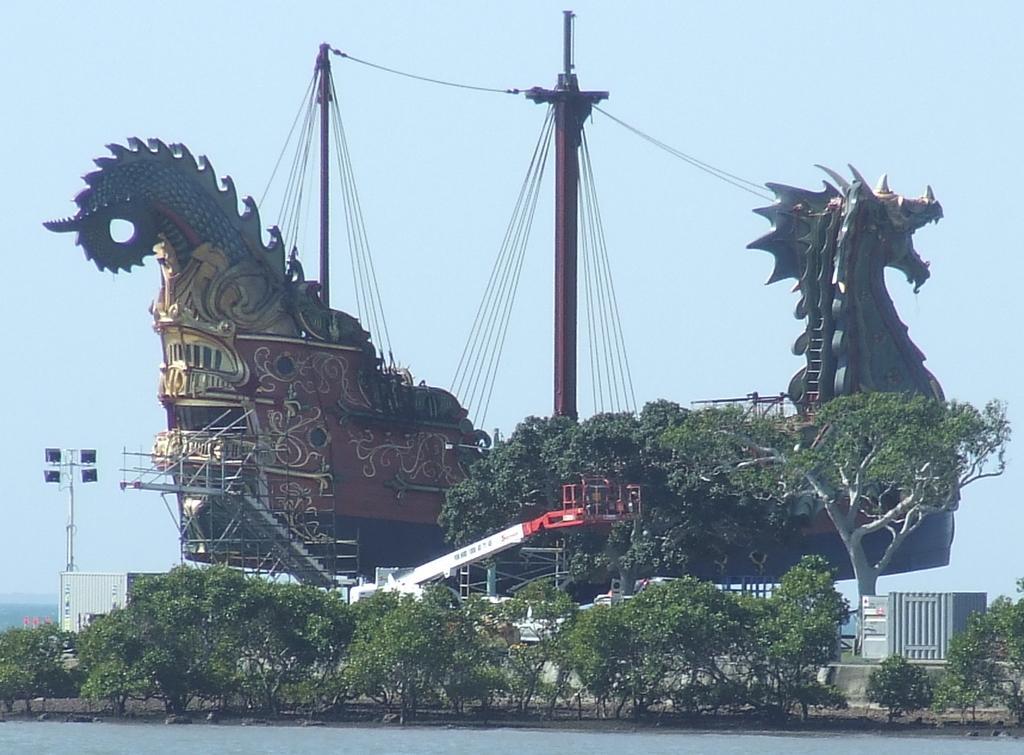In one or two sentences, can you explain what this image depicts? In the image in the center, we can see one dragon shape ship, poles, wires, trees, plants, staircase, fence, crane, road etc. In the background we can see the sky. 